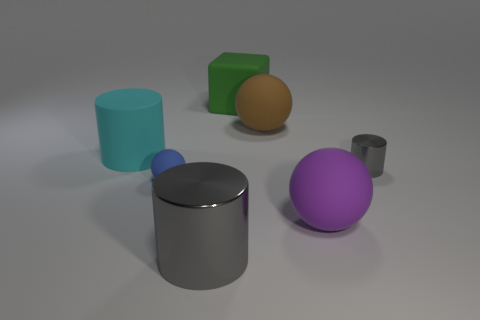There is a big thing that is on the right side of the green rubber object and in front of the small rubber sphere; what material is it?
Your response must be concise. Rubber. Do the brown rubber thing behind the cyan cylinder and the purple rubber thing have the same size?
Provide a short and direct response. Yes. What is the shape of the purple thing?
Provide a succinct answer. Sphere. How many other small things are the same shape as the brown rubber thing?
Offer a very short reply. 1. How many things are both in front of the big brown matte sphere and to the left of the small gray shiny cylinder?
Your answer should be compact. 4. The small matte object has what color?
Provide a succinct answer. Blue. Is there a tiny ball made of the same material as the large purple sphere?
Provide a short and direct response. Yes. There is a large sphere in front of the big sphere behind the big cyan matte cylinder; is there a large cyan matte cylinder right of it?
Ensure brevity in your answer.  No. There is a tiny blue matte sphere; are there any gray cylinders behind it?
Offer a very short reply. Yes. Are there any big cylinders of the same color as the small metallic cylinder?
Keep it short and to the point. Yes. 